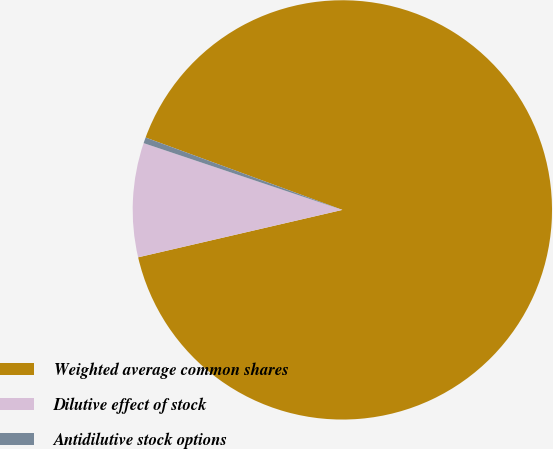Convert chart. <chart><loc_0><loc_0><loc_500><loc_500><pie_chart><fcel>Weighted average common shares<fcel>Dilutive effect of stock<fcel>Antidilutive stock options<nl><fcel>90.76%<fcel>8.79%<fcel>0.45%<nl></chart> 